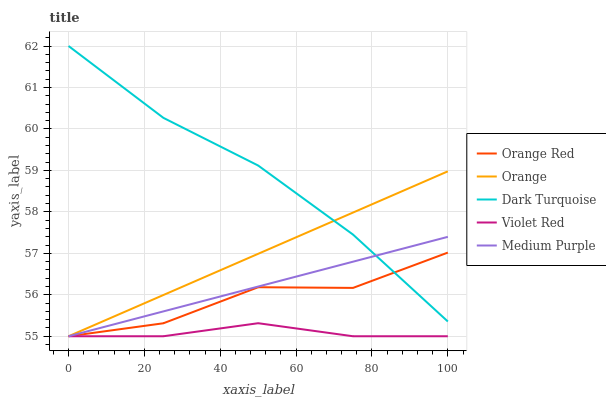Does Violet Red have the minimum area under the curve?
Answer yes or no. Yes. Does Dark Turquoise have the maximum area under the curve?
Answer yes or no. Yes. Does Dark Turquoise have the minimum area under the curve?
Answer yes or no. No. Does Violet Red have the maximum area under the curve?
Answer yes or no. No. Is Orange the smoothest?
Answer yes or no. Yes. Is Orange Red the roughest?
Answer yes or no. Yes. Is Dark Turquoise the smoothest?
Answer yes or no. No. Is Dark Turquoise the roughest?
Answer yes or no. No. Does Orange have the lowest value?
Answer yes or no. Yes. Does Dark Turquoise have the lowest value?
Answer yes or no. No. Does Dark Turquoise have the highest value?
Answer yes or no. Yes. Does Violet Red have the highest value?
Answer yes or no. No. Is Violet Red less than Dark Turquoise?
Answer yes or no. Yes. Is Dark Turquoise greater than Violet Red?
Answer yes or no. Yes. Does Medium Purple intersect Violet Red?
Answer yes or no. Yes. Is Medium Purple less than Violet Red?
Answer yes or no. No. Is Medium Purple greater than Violet Red?
Answer yes or no. No. Does Violet Red intersect Dark Turquoise?
Answer yes or no. No. 